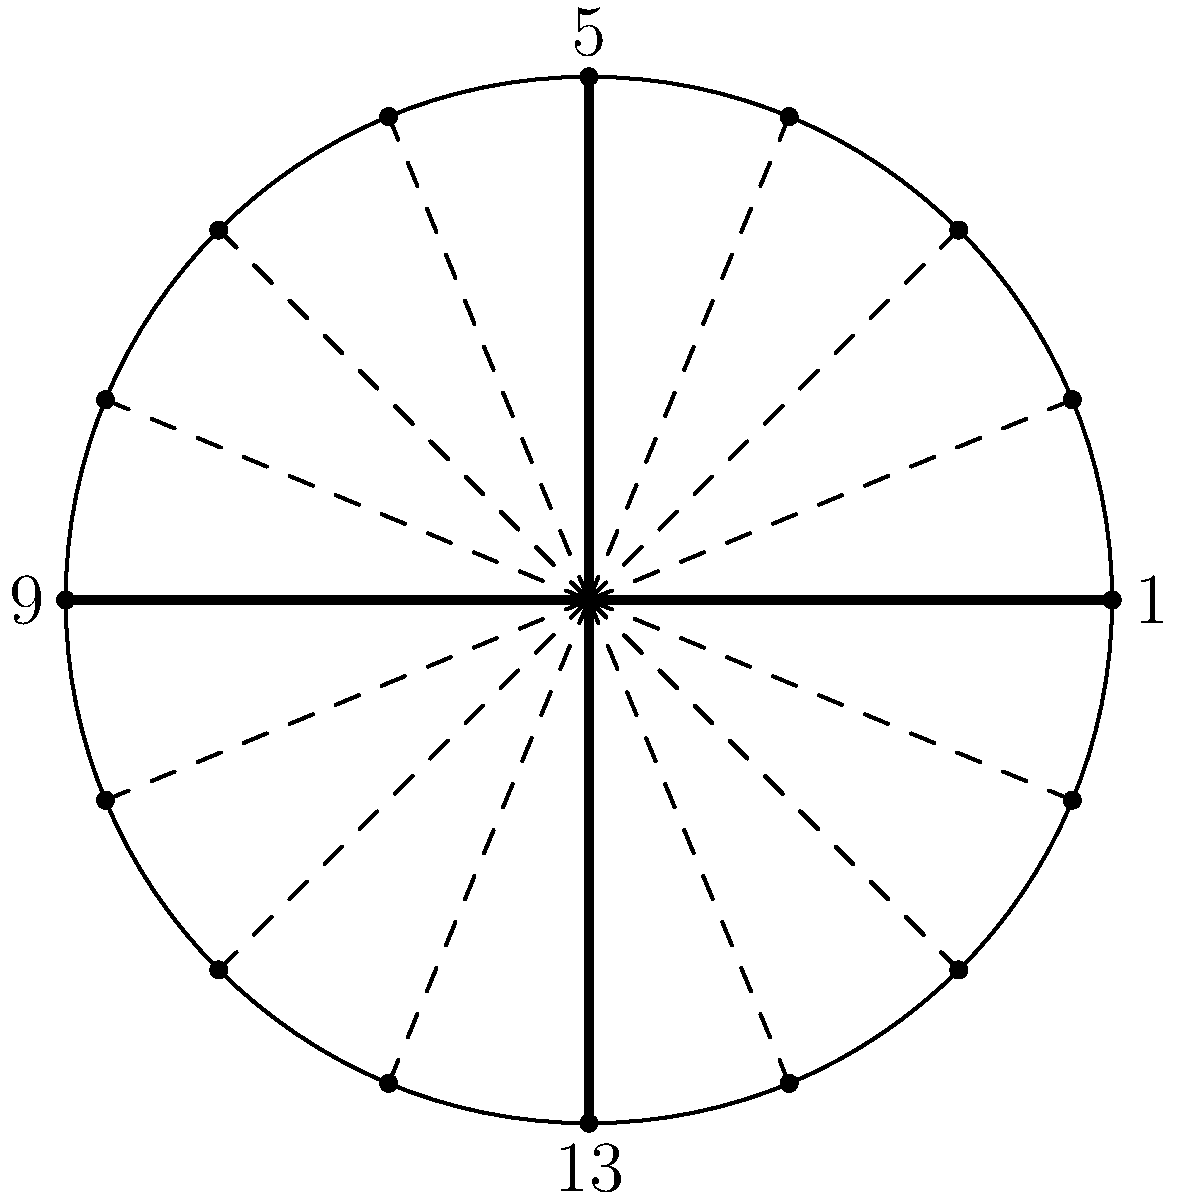The circular diagram above represents a 16-beat Tala cycle. If the ratio of strong beats to weak beats in this Tala is 1:3, how many strong beats are there in one complete cycle, and what are their positions on the diagram? To solve this problem, let's follow these steps:

1. Understand the given information:
   - The diagram represents a 16-beat Tala cycle.
   - The ratio of strong beats to weak beats is 1:3.

2. Calculate the total number of beats in one set of strong and weak beats:
   - 1 (strong) + 3 (weak) = 4 beats per set

3. Determine how many sets fit in the 16-beat cycle:
   - 16 ÷ 4 = 4 sets

4. Calculate the number of strong beats in one complete cycle:
   - Since there is 1 strong beat per set, and we have 4 sets:
   - Number of strong beats = 1 × 4 = 4 strong beats

5. Identify the positions of the strong beats:
   - In a 16-beat cycle, the strong beats will occur every 4 beats.
   - Starting from the first beat (labeled "1" on the diagram), we count:
     1, 5, 9, 13

6. Verify on the diagram:
   - The positions 1, 5, 9, and 13 correspond to the points where solid lines connect to the circle's circumference.

Therefore, there are 4 strong beats in one complete cycle, occurring at positions 1, 5, 9, and 13 on the diagram.
Answer: 4 strong beats at positions 1, 5, 9, and 13 